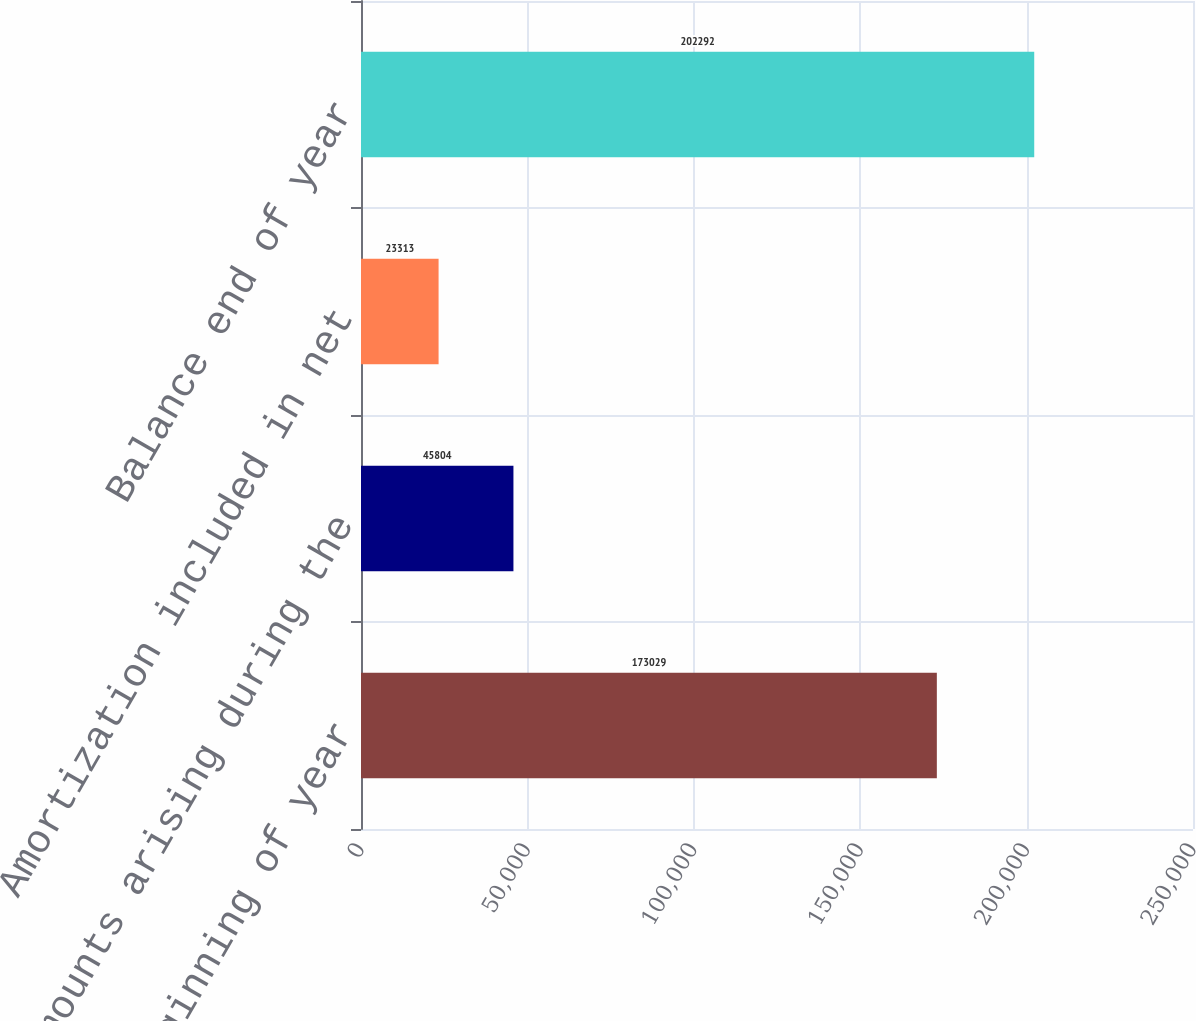Convert chart to OTSL. <chart><loc_0><loc_0><loc_500><loc_500><bar_chart><fcel>Balance beginning of year<fcel>Amounts arising during the<fcel>Amortization included in net<fcel>Balance end of year<nl><fcel>173029<fcel>45804<fcel>23313<fcel>202292<nl></chart> 